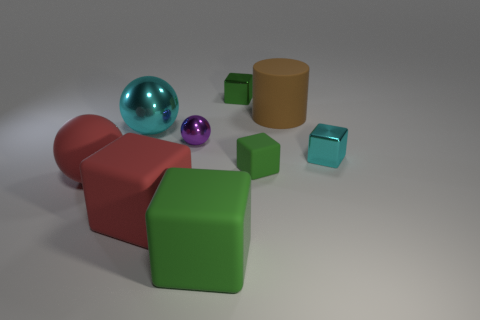What is the shape of the thing that is the same color as the large shiny sphere?
Your response must be concise. Cube. Is the rubber ball the same color as the cylinder?
Your response must be concise. No. How many large things are the same shape as the tiny purple object?
Offer a terse response. 2. What number of cubes are the same color as the matte sphere?
Make the answer very short. 1. Is the shape of the rubber thing in front of the big red rubber block the same as the red thing behind the red block?
Provide a short and direct response. No. How many green objects are in front of the shiny block that is right of the tiny shiny thing behind the large metallic sphere?
Provide a short and direct response. 2. The object that is left of the shiny ball that is left of the red rubber object that is in front of the big red matte sphere is made of what material?
Provide a succinct answer. Rubber. Are the tiny green cube that is behind the tiny cyan cube and the small sphere made of the same material?
Your answer should be very brief. Yes. How many cyan spheres have the same size as the red sphere?
Ensure brevity in your answer.  1. Are there more cyan spheres that are behind the tiny cyan metallic block than large brown cylinders in front of the red matte ball?
Provide a succinct answer. Yes. 